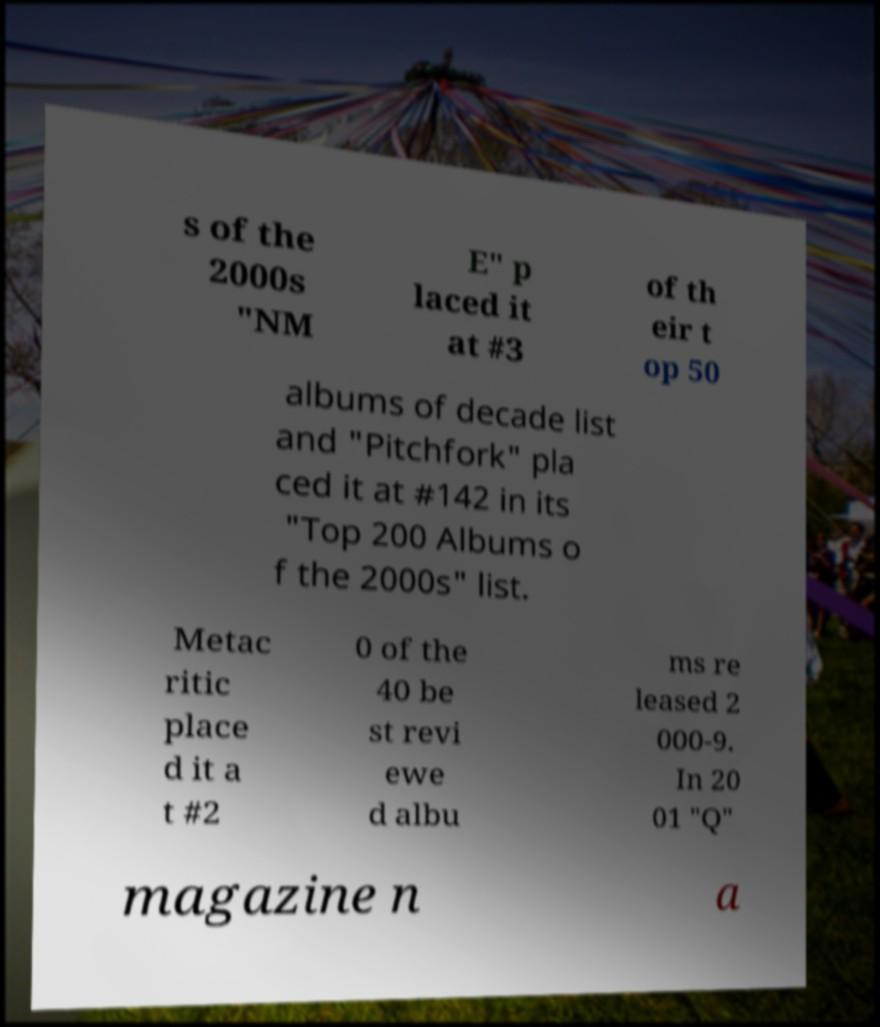I need the written content from this picture converted into text. Can you do that? s of the 2000s "NM E" p laced it at #3 of th eir t op 50 albums of decade list and "Pitchfork" pla ced it at #142 in its "Top 200 Albums o f the 2000s" list. Metac ritic place d it a t #2 0 of the 40 be st revi ewe d albu ms re leased 2 000-9. In 20 01 "Q" magazine n a 